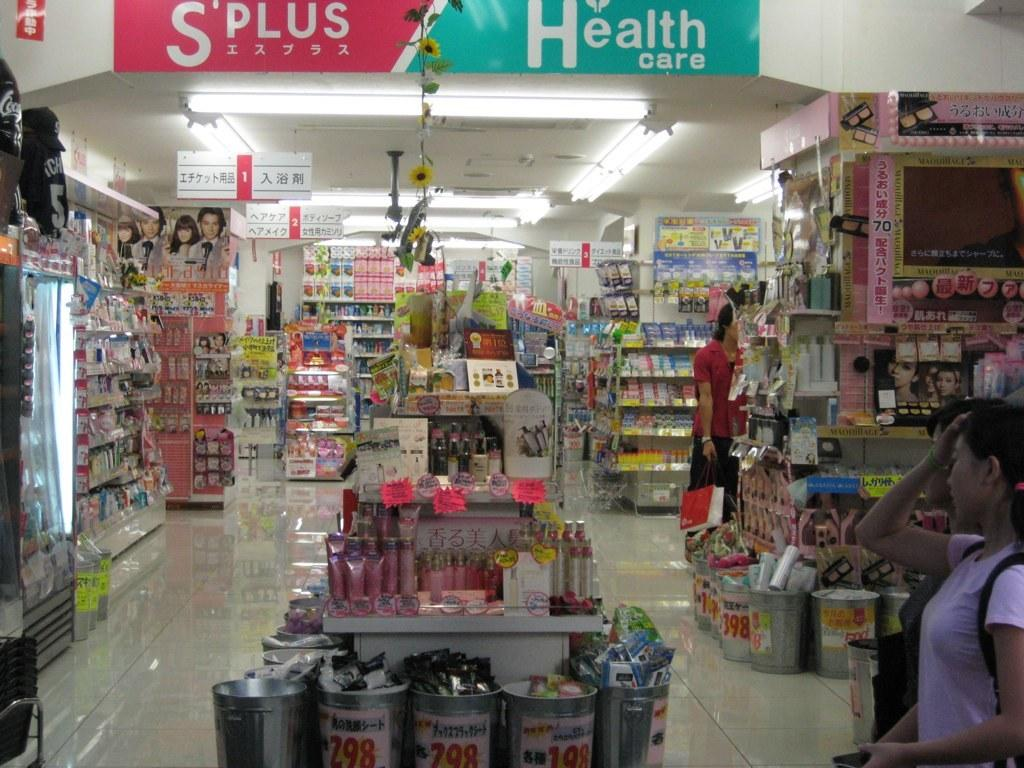<image>
Share a concise interpretation of the image provided. The teal sign on the right says health care 